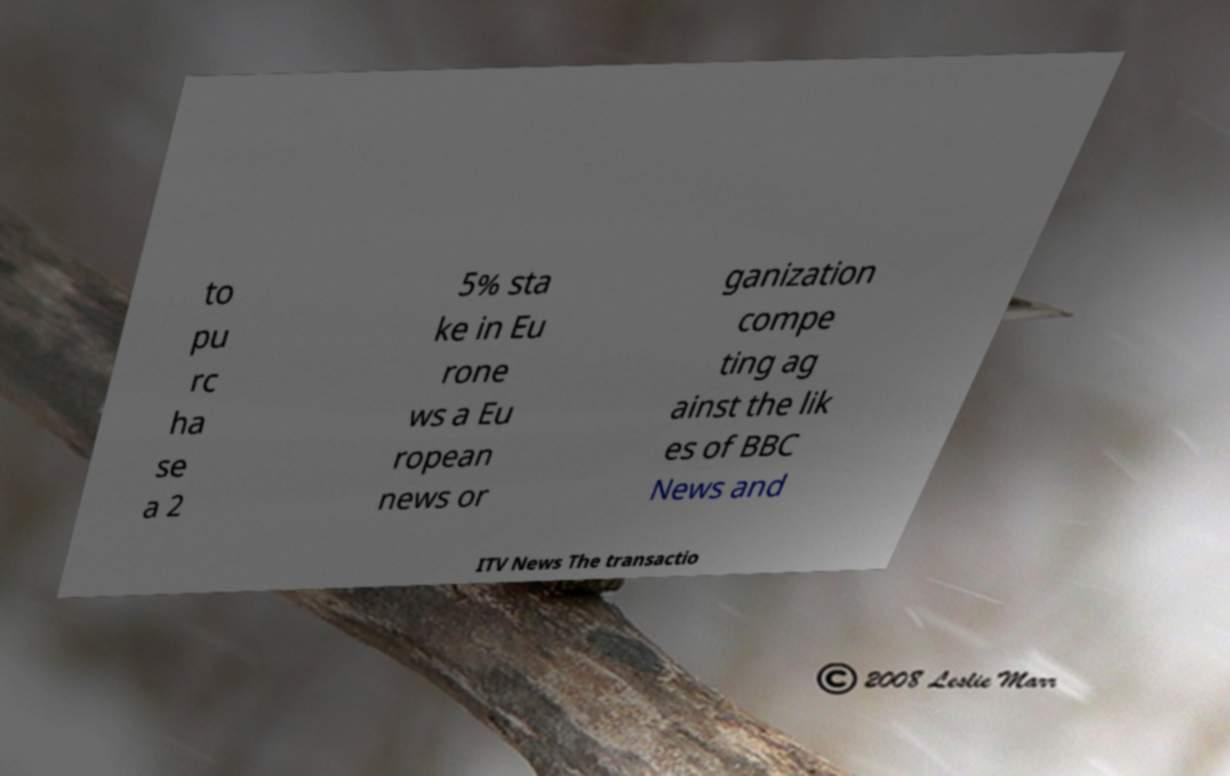For documentation purposes, I need the text within this image transcribed. Could you provide that? to pu rc ha se a 2 5% sta ke in Eu rone ws a Eu ropean news or ganization compe ting ag ainst the lik es of BBC News and ITV News The transactio 